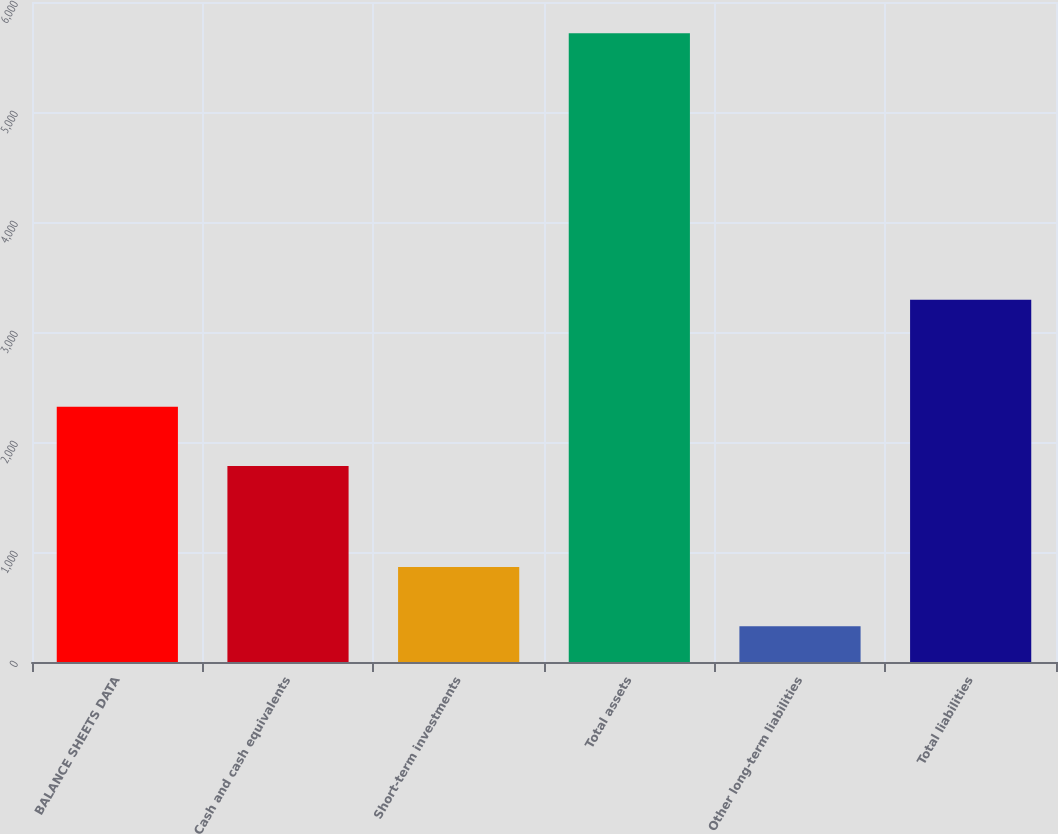Convert chart. <chart><loc_0><loc_0><loc_500><loc_500><bar_chart><fcel>BALANCE SHEETS DATA<fcel>Cash and cash equivalents<fcel>Short-term investments<fcel>Total assets<fcel>Other long-term liabilities<fcel>Total liabilities<nl><fcel>2321.2<fcel>1782<fcel>863.2<fcel>5716<fcel>324<fcel>3294<nl></chart> 